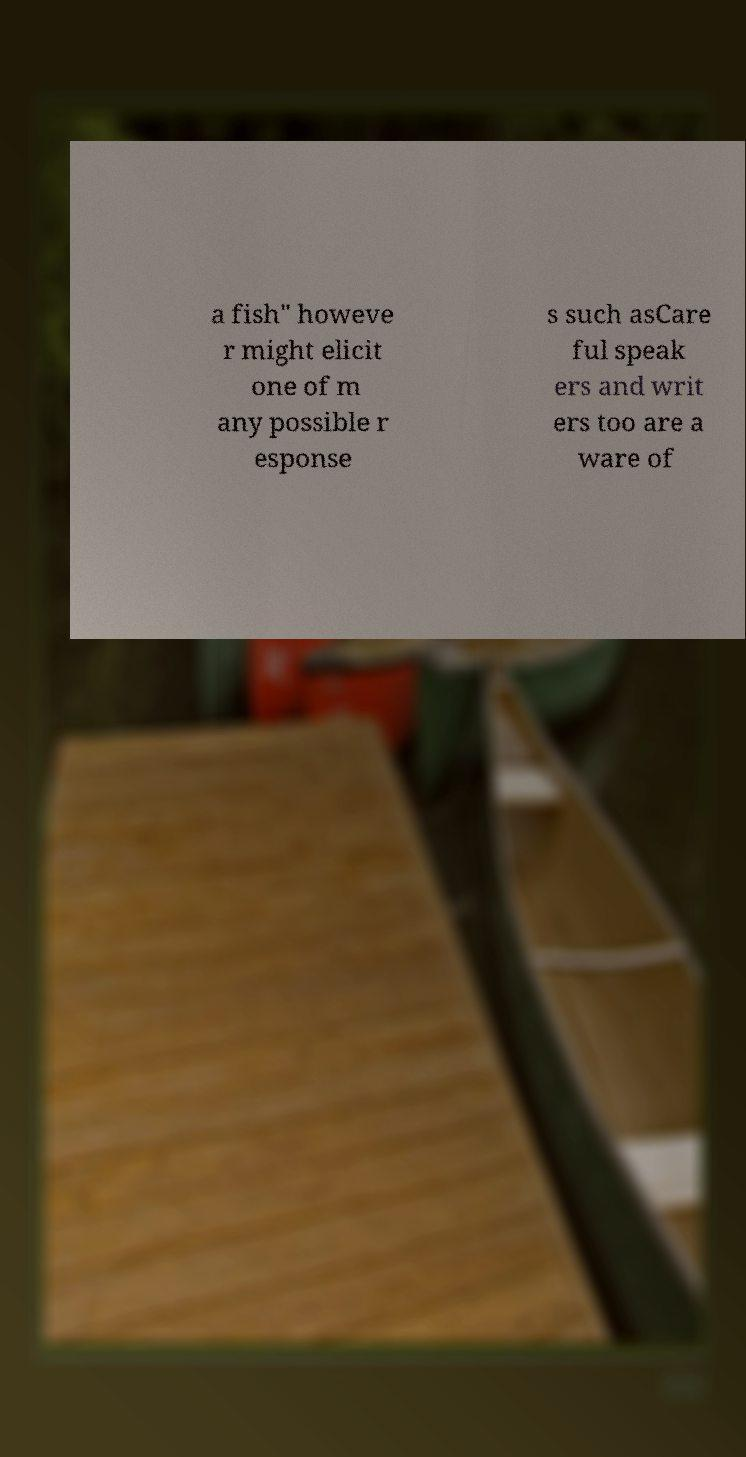Can you accurately transcribe the text from the provided image for me? a fish" howeve r might elicit one of m any possible r esponse s such asCare ful speak ers and writ ers too are a ware of 